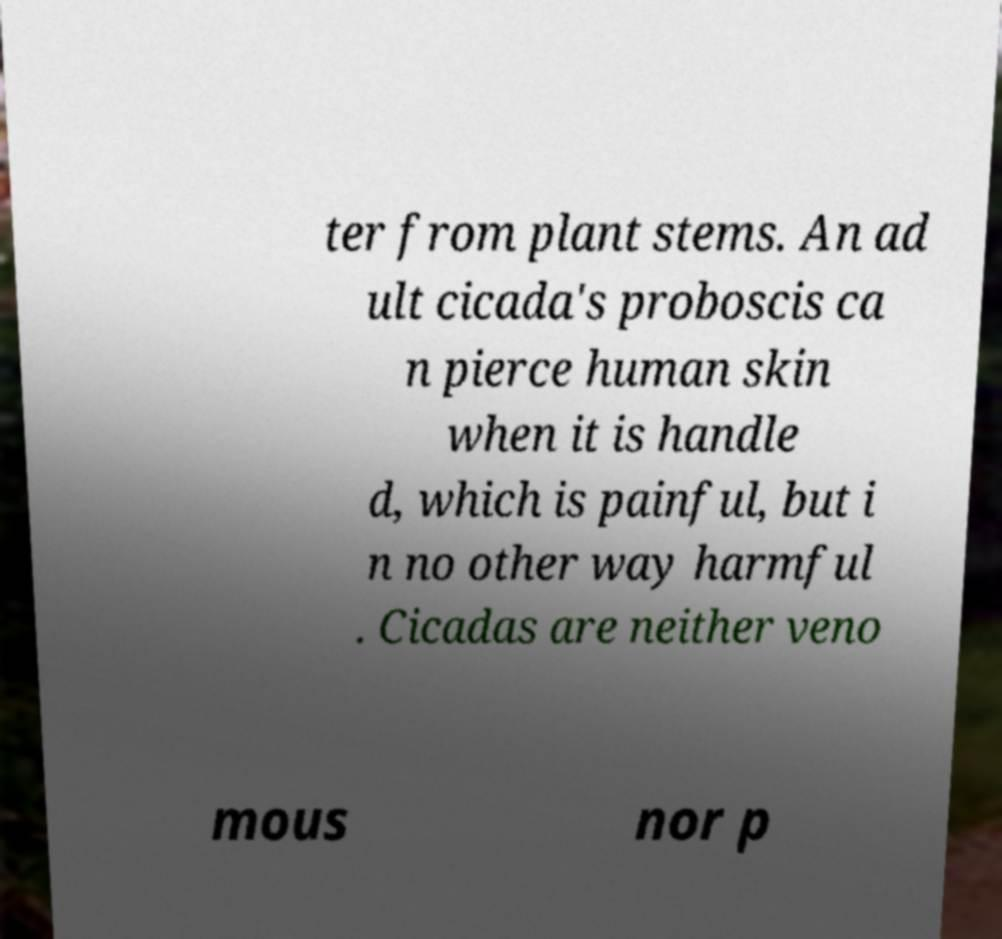Please read and relay the text visible in this image. What does it say? ter from plant stems. An ad ult cicada's proboscis ca n pierce human skin when it is handle d, which is painful, but i n no other way harmful . Cicadas are neither veno mous nor p 